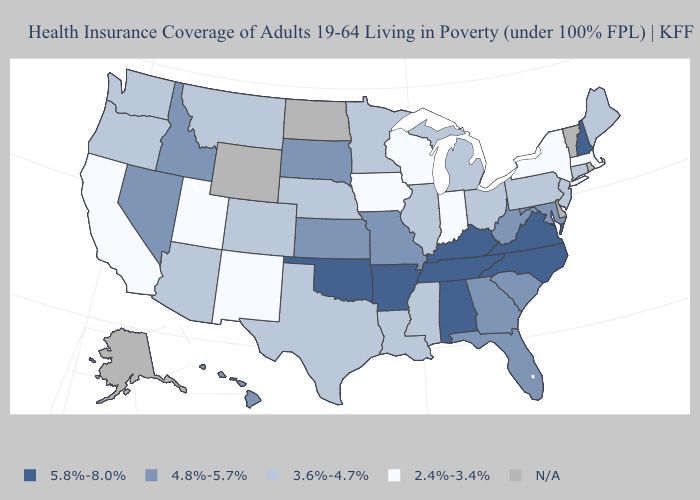Name the states that have a value in the range N/A?
Keep it brief. Alaska, Delaware, North Dakota, Rhode Island, Vermont, Wyoming. Does the map have missing data?
Quick response, please. Yes. Does New Mexico have the highest value in the West?
Short answer required. No. Among the states that border North Dakota , does South Dakota have the highest value?
Short answer required. Yes. Name the states that have a value in the range 3.6%-4.7%?
Answer briefly. Arizona, Colorado, Connecticut, Illinois, Louisiana, Maine, Michigan, Minnesota, Mississippi, Montana, Nebraska, New Jersey, Ohio, Oregon, Pennsylvania, Texas, Washington. Which states hav the highest value in the West?
Keep it brief. Hawaii, Idaho, Nevada. Which states have the lowest value in the USA?
Answer briefly. California, Indiana, Iowa, Massachusetts, New Mexico, New York, Utah, Wisconsin. Name the states that have a value in the range 2.4%-3.4%?
Quick response, please. California, Indiana, Iowa, Massachusetts, New Mexico, New York, Utah, Wisconsin. Name the states that have a value in the range N/A?
Be succinct. Alaska, Delaware, North Dakota, Rhode Island, Vermont, Wyoming. What is the highest value in states that border Louisiana?
Answer briefly. 5.8%-8.0%. Does California have the lowest value in the USA?
Give a very brief answer. Yes. What is the highest value in the USA?
Concise answer only. 5.8%-8.0%. Does Illinois have the highest value in the USA?
Concise answer only. No. What is the lowest value in the USA?
Write a very short answer. 2.4%-3.4%. 